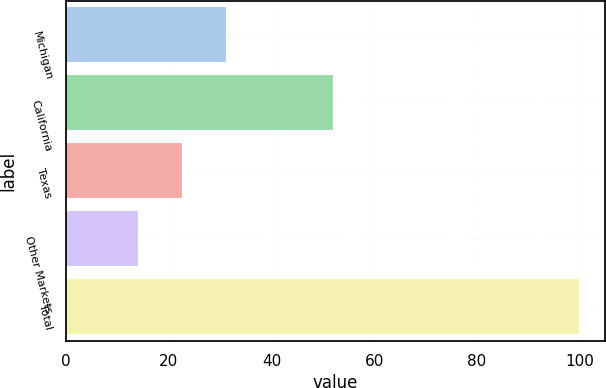<chart> <loc_0><loc_0><loc_500><loc_500><bar_chart><fcel>Michigan<fcel>California<fcel>Texas<fcel>Other Markets<fcel>Total<nl><fcel>31.2<fcel>52<fcel>22.6<fcel>14<fcel>100<nl></chart> 